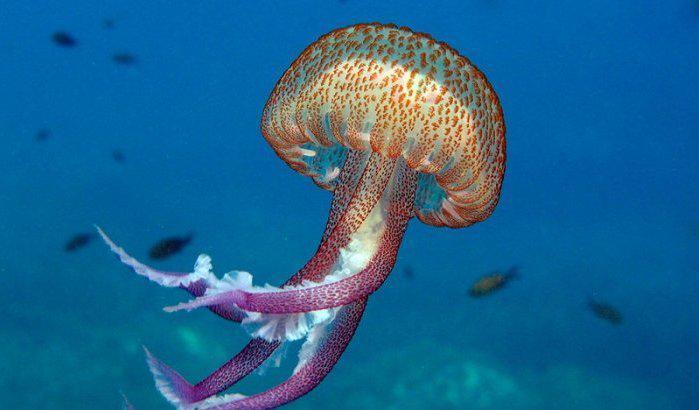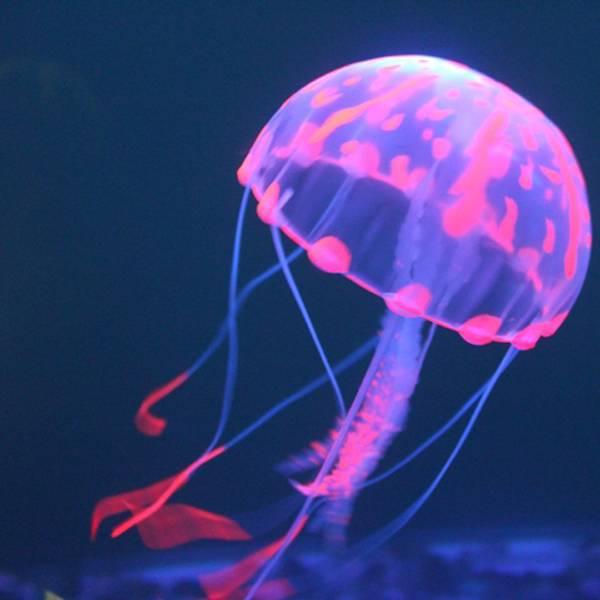The first image is the image on the left, the second image is the image on the right. Analyze the images presented: Is the assertion "Right image shows a single mushroom-shaped jellyfish with at least some neon blue tones." valid? Answer yes or no. Yes. 